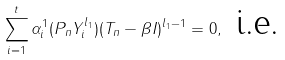<formula> <loc_0><loc_0><loc_500><loc_500>\sum _ { i = 1 } ^ { t } \alpha _ { i } ^ { 1 } ( P _ { n } Y ^ { l _ { 1 } } _ { i } ) ( T _ { n } - \beta I ) ^ { l _ { 1 } - 1 } = 0 , \text { i.e.}</formula> 